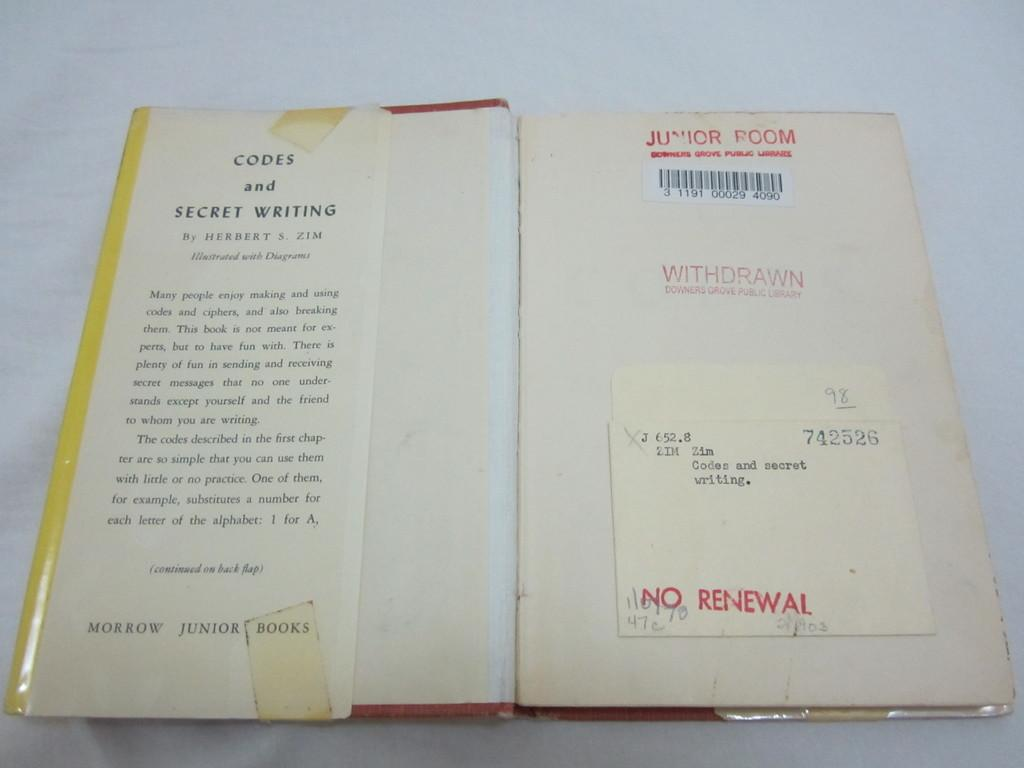Provide a one-sentence caption for the provided image. A copy of Codes and Secret Writing has been stamped with NO RENEWAL. 